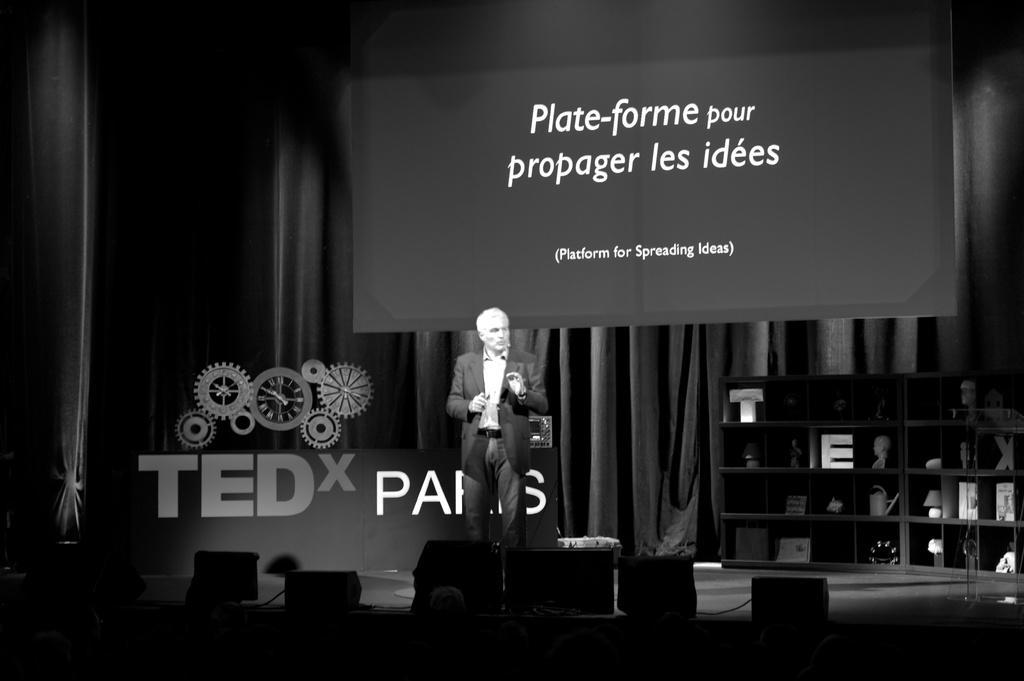Could you give a brief overview of what you see in this image? As we can see in the image there is a banner, rack, curtains, screen, a person wearing black color jacket and the image is little dark. 